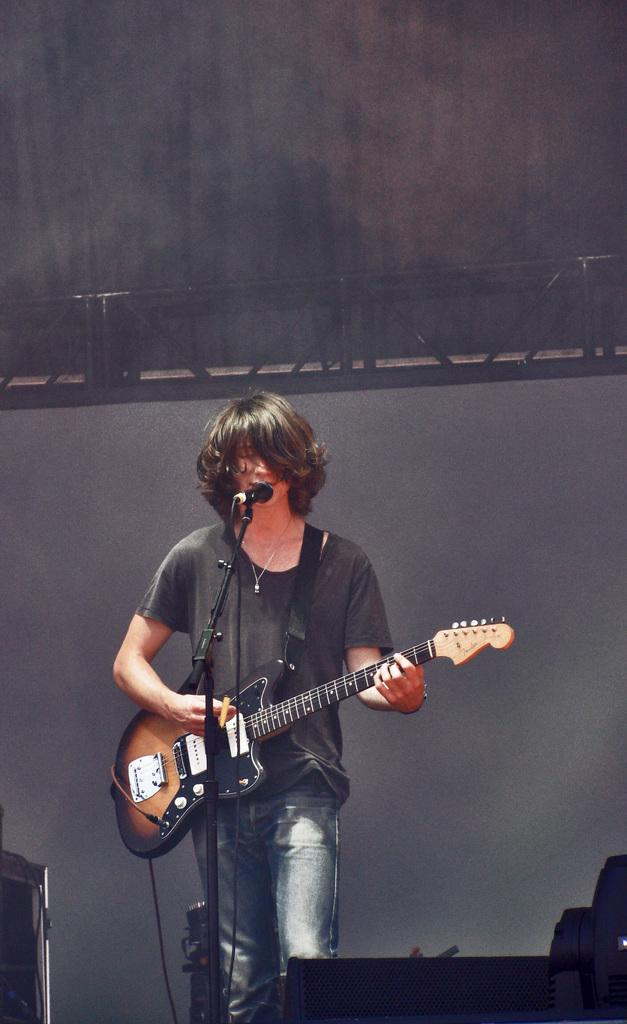Who is the main subject in the image? There is a man in the image. What is the man wearing? The man is wearing a t-shirt. What is the man doing in the image? The man is standing and playing the guitar. What object is in front of the man? There is a microphone stand in front of the man. Can you see a dog playing with a rake in the coal pile in the image? There is no dog, rake, or coal pile present in the image. 